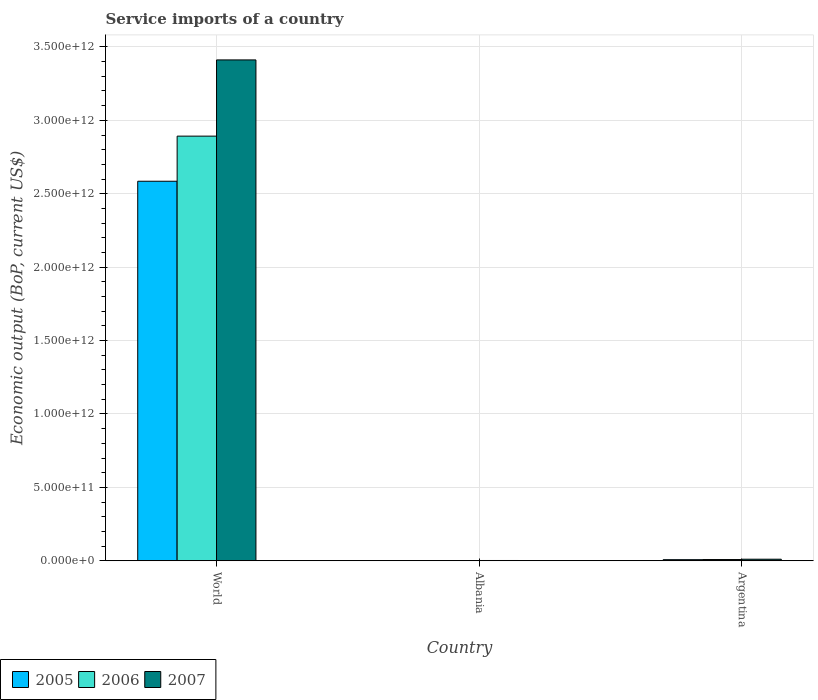How many groups of bars are there?
Offer a very short reply. 3. Are the number of bars per tick equal to the number of legend labels?
Make the answer very short. Yes. Are the number of bars on each tick of the X-axis equal?
Provide a succinct answer. Yes. How many bars are there on the 2nd tick from the left?
Keep it short and to the point. 3. What is the label of the 1st group of bars from the left?
Offer a terse response. World. What is the service imports in 2007 in Albania?
Make the answer very short. 1.92e+09. Across all countries, what is the maximum service imports in 2006?
Keep it short and to the point. 2.89e+12. Across all countries, what is the minimum service imports in 2007?
Your response must be concise. 1.92e+09. In which country was the service imports in 2005 minimum?
Your answer should be compact. Albania. What is the total service imports in 2006 in the graph?
Your answer should be very brief. 2.90e+12. What is the difference between the service imports in 2005 in Albania and that in World?
Offer a very short reply. -2.58e+12. What is the difference between the service imports in 2007 in Albania and the service imports in 2005 in Argentina?
Make the answer very short. -5.57e+09. What is the average service imports in 2007 per country?
Provide a succinct answer. 1.14e+12. What is the difference between the service imports of/in 2006 and service imports of/in 2007 in Argentina?
Provide a succinct answer. -2.32e+09. In how many countries, is the service imports in 2007 greater than 1300000000000 US$?
Keep it short and to the point. 1. What is the ratio of the service imports in 2005 in Albania to that in Argentina?
Offer a very short reply. 0.18. Is the service imports in 2007 in Albania less than that in World?
Keep it short and to the point. Yes. Is the difference between the service imports in 2006 in Albania and Argentina greater than the difference between the service imports in 2007 in Albania and Argentina?
Keep it short and to the point. Yes. What is the difference between the highest and the second highest service imports in 2007?
Give a very brief answer. 8.78e+09. What is the difference between the highest and the lowest service imports in 2005?
Keep it short and to the point. 2.58e+12. In how many countries, is the service imports in 2007 greater than the average service imports in 2007 taken over all countries?
Provide a succinct answer. 1. What does the 2nd bar from the left in Argentina represents?
Ensure brevity in your answer.  2006. Are all the bars in the graph horizontal?
Ensure brevity in your answer.  No. How many countries are there in the graph?
Provide a succinct answer. 3. What is the difference between two consecutive major ticks on the Y-axis?
Your answer should be compact. 5.00e+11. How many legend labels are there?
Give a very brief answer. 3. How are the legend labels stacked?
Offer a very short reply. Horizontal. What is the title of the graph?
Keep it short and to the point. Service imports of a country. What is the label or title of the Y-axis?
Make the answer very short. Economic output (BoP, current US$). What is the Economic output (BoP, current US$) in 2005 in World?
Keep it short and to the point. 2.59e+12. What is the Economic output (BoP, current US$) in 2006 in World?
Your answer should be very brief. 2.89e+12. What is the Economic output (BoP, current US$) in 2007 in World?
Your answer should be very brief. 3.41e+12. What is the Economic output (BoP, current US$) of 2005 in Albania?
Your response must be concise. 1.38e+09. What is the Economic output (BoP, current US$) in 2006 in Albania?
Ensure brevity in your answer.  1.57e+09. What is the Economic output (BoP, current US$) in 2007 in Albania?
Keep it short and to the point. 1.92e+09. What is the Economic output (BoP, current US$) of 2005 in Argentina?
Offer a very short reply. 7.50e+09. What is the Economic output (BoP, current US$) in 2006 in Argentina?
Make the answer very short. 8.39e+09. What is the Economic output (BoP, current US$) in 2007 in Argentina?
Make the answer very short. 1.07e+1. Across all countries, what is the maximum Economic output (BoP, current US$) of 2005?
Offer a very short reply. 2.59e+12. Across all countries, what is the maximum Economic output (BoP, current US$) of 2006?
Provide a short and direct response. 2.89e+12. Across all countries, what is the maximum Economic output (BoP, current US$) of 2007?
Give a very brief answer. 3.41e+12. Across all countries, what is the minimum Economic output (BoP, current US$) in 2005?
Keep it short and to the point. 1.38e+09. Across all countries, what is the minimum Economic output (BoP, current US$) of 2006?
Offer a terse response. 1.57e+09. Across all countries, what is the minimum Economic output (BoP, current US$) in 2007?
Your response must be concise. 1.92e+09. What is the total Economic output (BoP, current US$) of 2005 in the graph?
Your answer should be compact. 2.59e+12. What is the total Economic output (BoP, current US$) of 2006 in the graph?
Offer a very short reply. 2.90e+12. What is the total Economic output (BoP, current US$) of 2007 in the graph?
Provide a succinct answer. 3.42e+12. What is the difference between the Economic output (BoP, current US$) of 2005 in World and that in Albania?
Keep it short and to the point. 2.58e+12. What is the difference between the Economic output (BoP, current US$) of 2006 in World and that in Albania?
Offer a very short reply. 2.89e+12. What is the difference between the Economic output (BoP, current US$) of 2007 in World and that in Albania?
Your answer should be very brief. 3.41e+12. What is the difference between the Economic output (BoP, current US$) of 2005 in World and that in Argentina?
Your response must be concise. 2.58e+12. What is the difference between the Economic output (BoP, current US$) of 2006 in World and that in Argentina?
Offer a very short reply. 2.88e+12. What is the difference between the Economic output (BoP, current US$) of 2007 in World and that in Argentina?
Keep it short and to the point. 3.40e+12. What is the difference between the Economic output (BoP, current US$) in 2005 in Albania and that in Argentina?
Your answer should be very brief. -6.11e+09. What is the difference between the Economic output (BoP, current US$) in 2006 in Albania and that in Argentina?
Keep it short and to the point. -6.81e+09. What is the difference between the Economic output (BoP, current US$) in 2007 in Albania and that in Argentina?
Ensure brevity in your answer.  -8.78e+09. What is the difference between the Economic output (BoP, current US$) in 2005 in World and the Economic output (BoP, current US$) in 2006 in Albania?
Ensure brevity in your answer.  2.58e+12. What is the difference between the Economic output (BoP, current US$) of 2005 in World and the Economic output (BoP, current US$) of 2007 in Albania?
Your answer should be very brief. 2.58e+12. What is the difference between the Economic output (BoP, current US$) of 2006 in World and the Economic output (BoP, current US$) of 2007 in Albania?
Your answer should be compact. 2.89e+12. What is the difference between the Economic output (BoP, current US$) in 2005 in World and the Economic output (BoP, current US$) in 2006 in Argentina?
Ensure brevity in your answer.  2.58e+12. What is the difference between the Economic output (BoP, current US$) of 2005 in World and the Economic output (BoP, current US$) of 2007 in Argentina?
Ensure brevity in your answer.  2.57e+12. What is the difference between the Economic output (BoP, current US$) of 2006 in World and the Economic output (BoP, current US$) of 2007 in Argentina?
Keep it short and to the point. 2.88e+12. What is the difference between the Economic output (BoP, current US$) in 2005 in Albania and the Economic output (BoP, current US$) in 2006 in Argentina?
Your response must be concise. -7.00e+09. What is the difference between the Economic output (BoP, current US$) of 2005 in Albania and the Economic output (BoP, current US$) of 2007 in Argentina?
Offer a very short reply. -9.32e+09. What is the difference between the Economic output (BoP, current US$) of 2006 in Albania and the Economic output (BoP, current US$) of 2007 in Argentina?
Keep it short and to the point. -9.13e+09. What is the average Economic output (BoP, current US$) of 2005 per country?
Keep it short and to the point. 8.65e+11. What is the average Economic output (BoP, current US$) in 2006 per country?
Offer a terse response. 9.67e+11. What is the average Economic output (BoP, current US$) in 2007 per country?
Ensure brevity in your answer.  1.14e+12. What is the difference between the Economic output (BoP, current US$) of 2005 and Economic output (BoP, current US$) of 2006 in World?
Offer a terse response. -3.07e+11. What is the difference between the Economic output (BoP, current US$) in 2005 and Economic output (BoP, current US$) in 2007 in World?
Your answer should be very brief. -8.26e+11. What is the difference between the Economic output (BoP, current US$) in 2006 and Economic output (BoP, current US$) in 2007 in World?
Provide a short and direct response. -5.19e+11. What is the difference between the Economic output (BoP, current US$) of 2005 and Economic output (BoP, current US$) of 2006 in Albania?
Your answer should be compact. -1.90e+08. What is the difference between the Economic output (BoP, current US$) of 2005 and Economic output (BoP, current US$) of 2007 in Albania?
Your answer should be compact. -5.42e+08. What is the difference between the Economic output (BoP, current US$) of 2006 and Economic output (BoP, current US$) of 2007 in Albania?
Ensure brevity in your answer.  -3.51e+08. What is the difference between the Economic output (BoP, current US$) in 2005 and Economic output (BoP, current US$) in 2006 in Argentina?
Offer a very short reply. -8.89e+08. What is the difference between the Economic output (BoP, current US$) of 2005 and Economic output (BoP, current US$) of 2007 in Argentina?
Give a very brief answer. -3.20e+09. What is the difference between the Economic output (BoP, current US$) in 2006 and Economic output (BoP, current US$) in 2007 in Argentina?
Give a very brief answer. -2.32e+09. What is the ratio of the Economic output (BoP, current US$) in 2005 in World to that in Albania?
Your answer should be compact. 1869.34. What is the ratio of the Economic output (BoP, current US$) of 2006 in World to that in Albania?
Give a very brief answer. 1838.32. What is the ratio of the Economic output (BoP, current US$) of 2007 in World to that in Albania?
Your answer should be very brief. 1772.68. What is the ratio of the Economic output (BoP, current US$) in 2005 in World to that in Argentina?
Give a very brief answer. 344.82. What is the ratio of the Economic output (BoP, current US$) in 2006 in World to that in Argentina?
Offer a very short reply. 344.91. What is the ratio of the Economic output (BoP, current US$) in 2007 in World to that in Argentina?
Provide a short and direct response. 318.77. What is the ratio of the Economic output (BoP, current US$) of 2005 in Albania to that in Argentina?
Make the answer very short. 0.18. What is the ratio of the Economic output (BoP, current US$) in 2006 in Albania to that in Argentina?
Give a very brief answer. 0.19. What is the ratio of the Economic output (BoP, current US$) in 2007 in Albania to that in Argentina?
Make the answer very short. 0.18. What is the difference between the highest and the second highest Economic output (BoP, current US$) in 2005?
Offer a terse response. 2.58e+12. What is the difference between the highest and the second highest Economic output (BoP, current US$) in 2006?
Offer a terse response. 2.88e+12. What is the difference between the highest and the second highest Economic output (BoP, current US$) of 2007?
Your response must be concise. 3.40e+12. What is the difference between the highest and the lowest Economic output (BoP, current US$) in 2005?
Your response must be concise. 2.58e+12. What is the difference between the highest and the lowest Economic output (BoP, current US$) in 2006?
Keep it short and to the point. 2.89e+12. What is the difference between the highest and the lowest Economic output (BoP, current US$) in 2007?
Your response must be concise. 3.41e+12. 